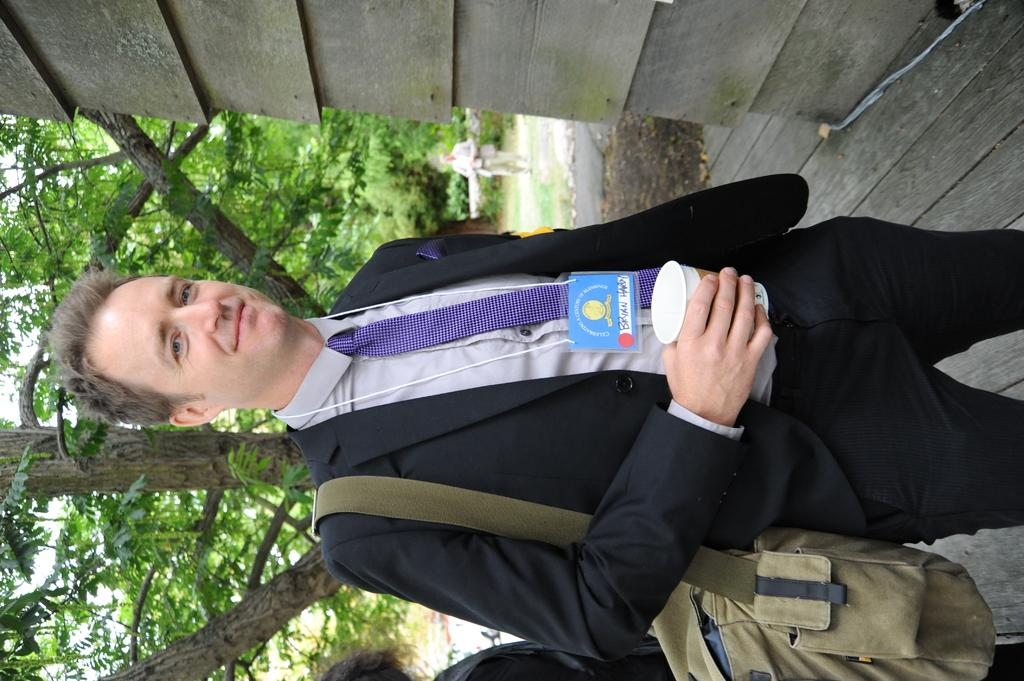What is the man in the image doing? The man is standing in the image and holding a disposal tumbler in his hands. Can you describe the people in the background of the image? There are persons standing in the background of the image. What can be seen in the background of the image besides people? Trees, buildings, and the sky are visible in the background of the image. What type of quilt is being used to cover the trees in the image? There is no quilt present in the image, and the trees are not covered. Can you hear the wren singing in the image? There is no mention of a wren or any sounds in the image, so it cannot be determined if a wren is singing. 